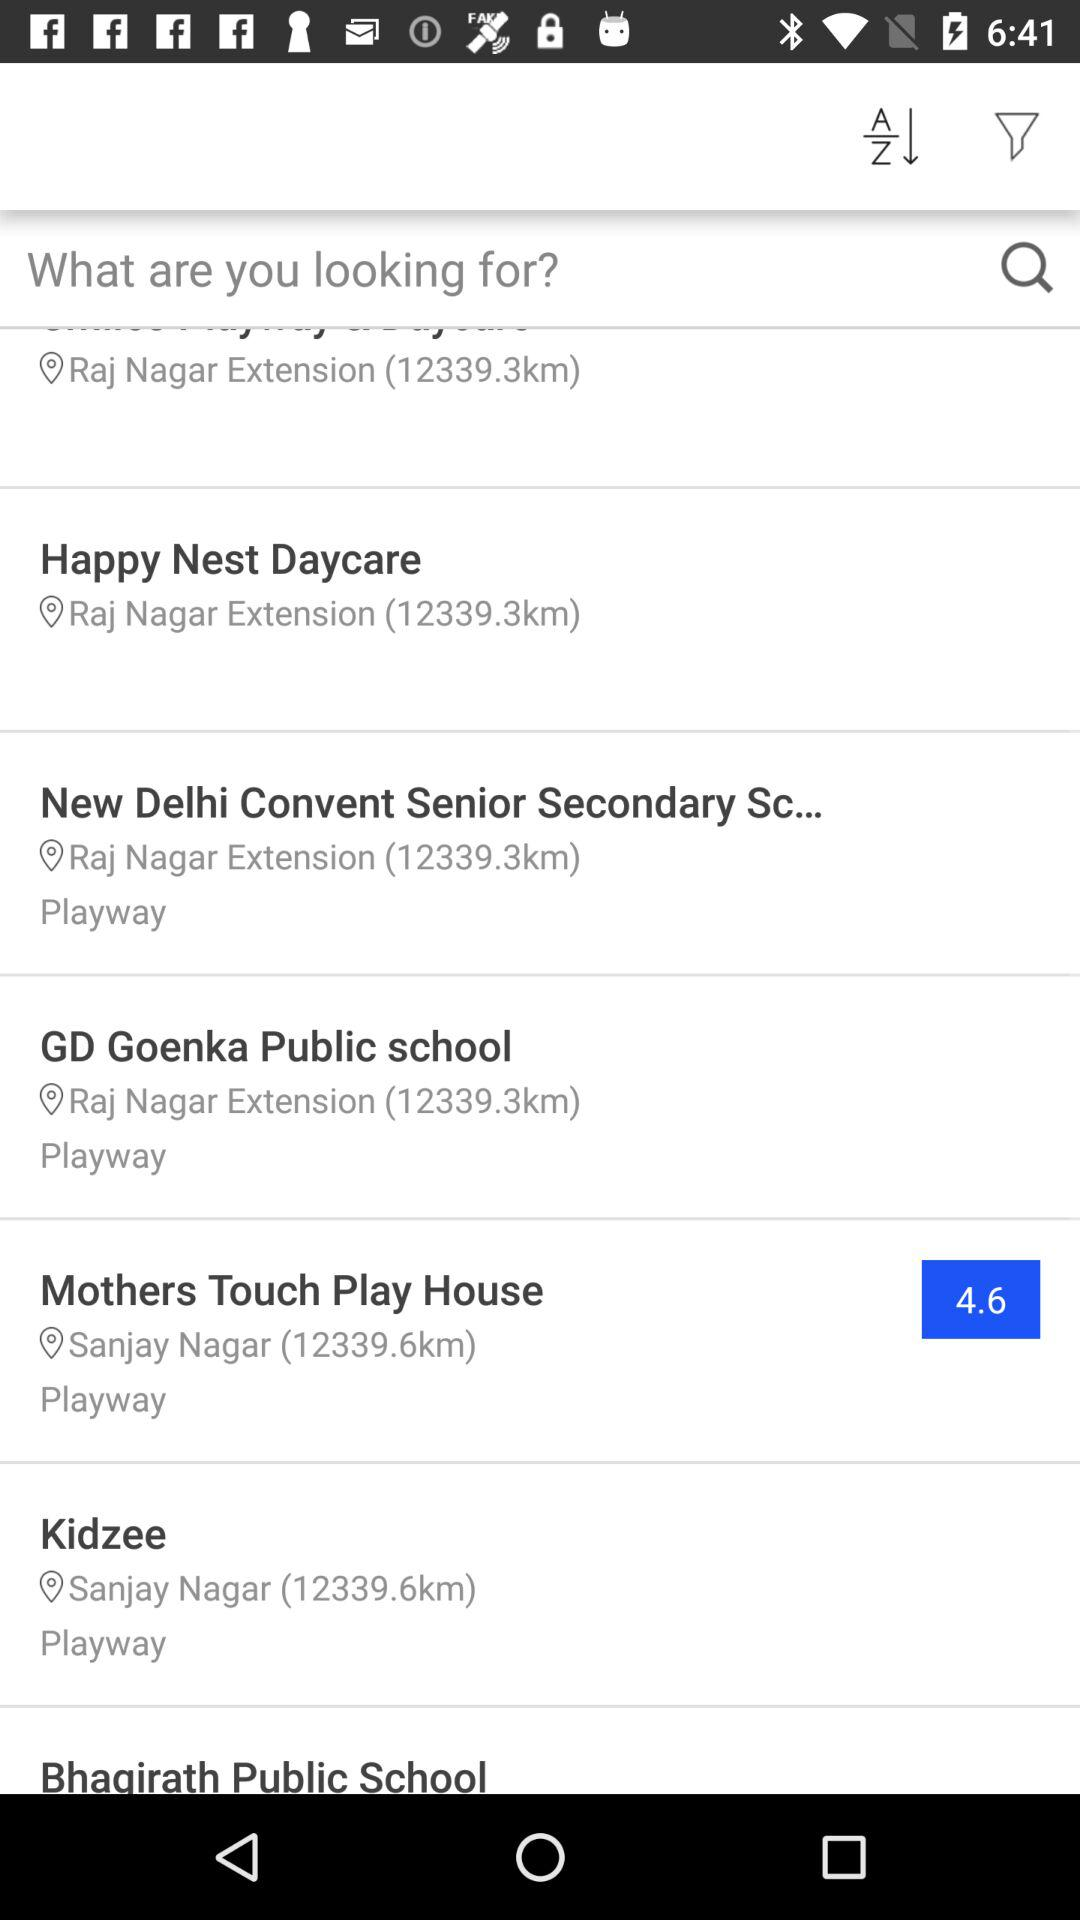What is the distance between Kidzee and my location? The distance between Kidzee and my location is 12339.6km. 